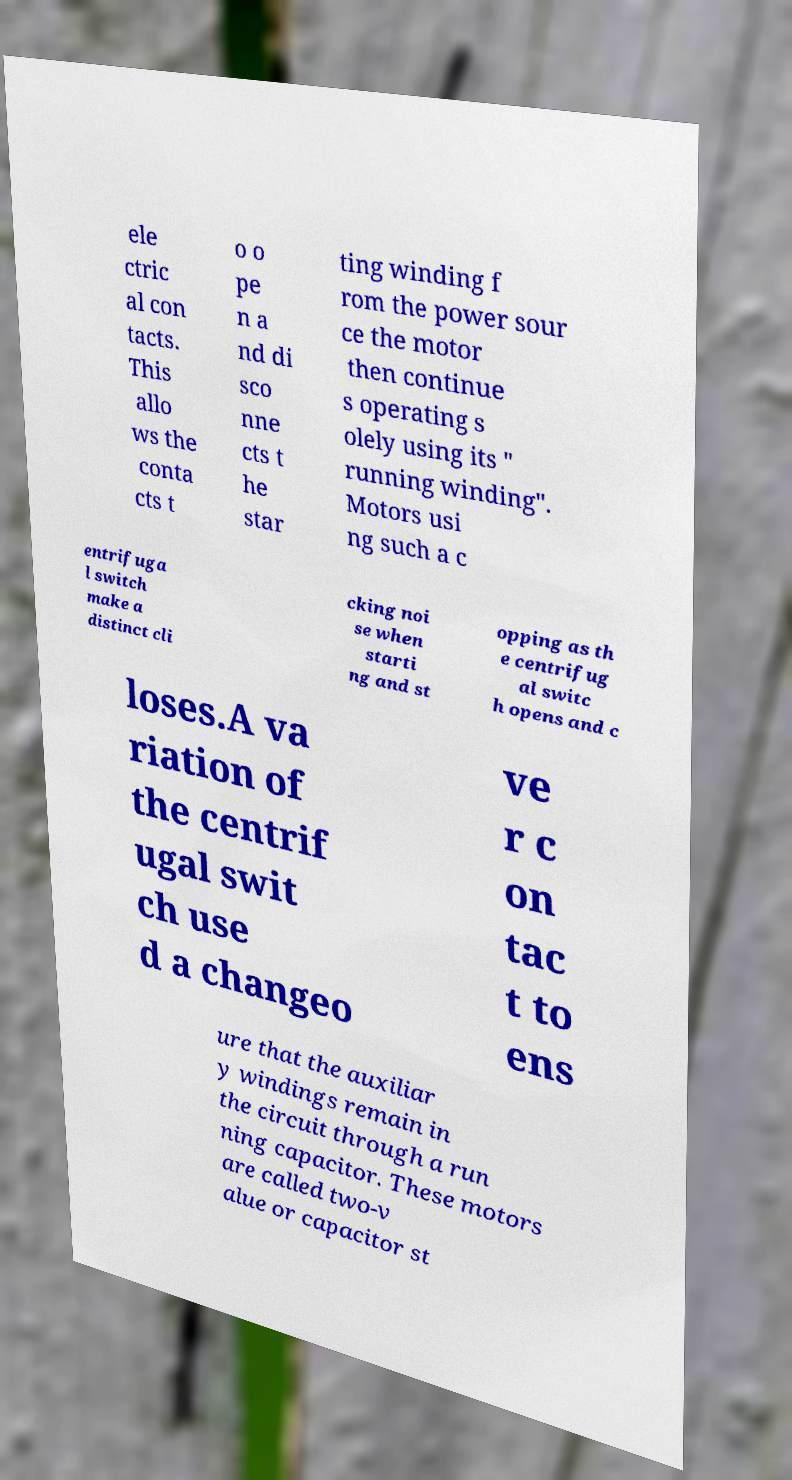Can you read and provide the text displayed in the image?This photo seems to have some interesting text. Can you extract and type it out for me? ele ctric al con tacts. This allo ws the conta cts t o o pe n a nd di sco nne cts t he star ting winding f rom the power sour ce the motor then continue s operating s olely using its " running winding". Motors usi ng such a c entrifuga l switch make a distinct cli cking noi se when starti ng and st opping as th e centrifug al switc h opens and c loses.A va riation of the centrif ugal swit ch use d a changeo ve r c on tac t to ens ure that the auxiliar y windings remain in the circuit through a run ning capacitor. These motors are called two-v alue or capacitor st 